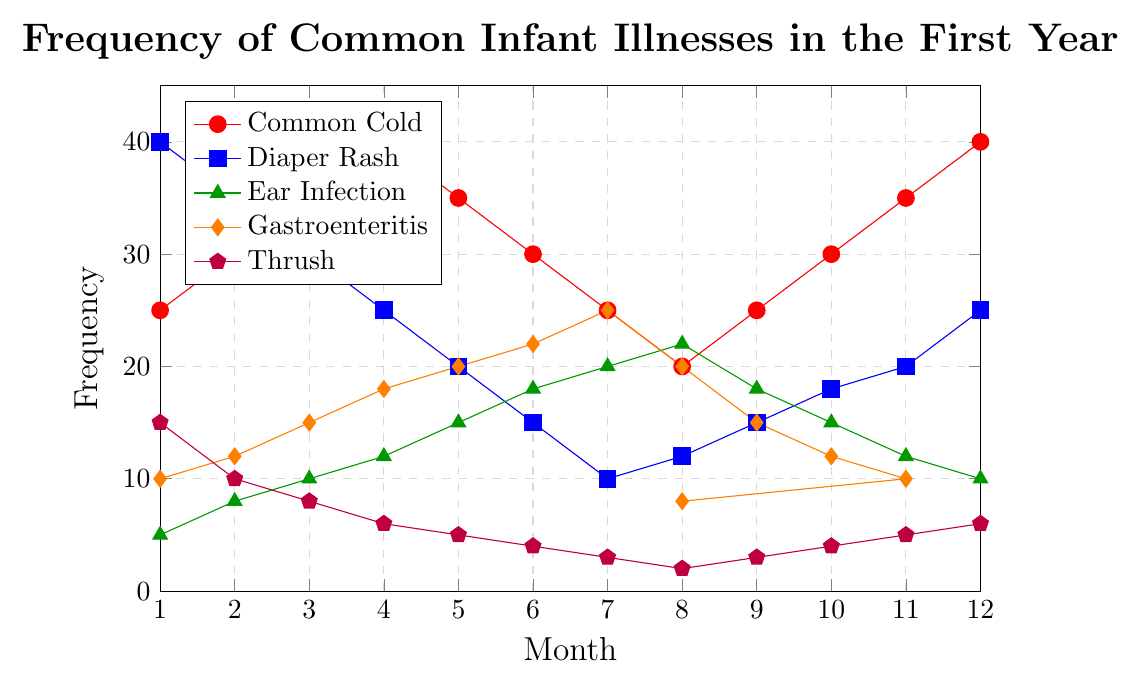what is the highest recorded frequency for the common cold in any month? The line representing the common cold (red) peaks at the top of the figure twice, first in month 4 and then again in month 12. Both show a value of 40.
Answer: 40 In which month was Diaper Rash least frequent, and what was its frequency? The blue line representing Diaper Rash is lowest in month 7, where it touches the 10 mark.
Answer: Month 7, 10 How does the frequency of Ear Infections change between month 1 and month 12? The green line for Ear Infections starts at 5 in month 1 and increases steadily to a peak at month 7 (20), and then decreases back to 10 by month 12.
Answer: Increases, then decreases What is the difference in the frequency of Gastroenteritis between month 6 and month 12? In month 6, Gastroenteritis (orange line) is at 22, while in month 12, it drops to 8. The difference is 22 - 8.
Answer: 14 Comparing Common Cold and Diaper Rash, in which month do their frequencies intersect and what is that frequency? Both the red and blue lines intersect only once, which is in month 9 at a frequency of 25.
Answer: Month 9, 25 On average, how many cases of Thrush occurred from month 1 to month 12? The values for Thrush (purple line) are 15, 10, 8, 6, 5, 4, 3, 2, 3, 4, 5, 6. Summing these values gives 71. Dividing by 12 months, the average is 71 / 12 ≈ 5.92.
Answer: 5.92 How many months see a decrease in the frequency of the Common Cold compared to the previous month? Observing the red line, we see it decreases from month 5 (35) to 6 (30), from month 6 (30) to 7 (25), and from month 12 (40) to 1 (tied, reset). There are three months of decrease.
Answer: 3 months In which months is the frequency of Ear Infection exactly 12? The green line indicates an Ear Infection frequency of 12 in months 4 and 11.
Answer: Months 4 and 11 Which illness has the least fluctuation in frequency throughout the year? Comparing the amplitude of fluctuations for all lines, the line for Thrush (purple) changes the least, from 15 to 2, with a range of only 13.
Answer: Thrush 